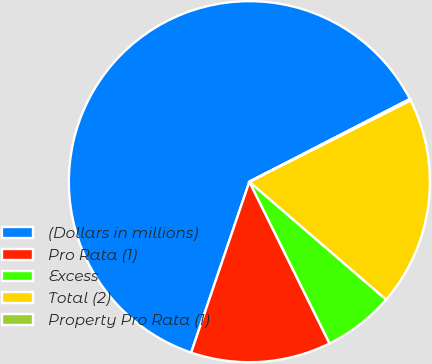<chart> <loc_0><loc_0><loc_500><loc_500><pie_chart><fcel>(Dollars in millions)<fcel>Pro Rata (1)<fcel>Excess<fcel>Total (2)<fcel>Property Pro Rata (1)<nl><fcel>62.2%<fcel>12.55%<fcel>6.35%<fcel>18.76%<fcel>0.14%<nl></chart> 